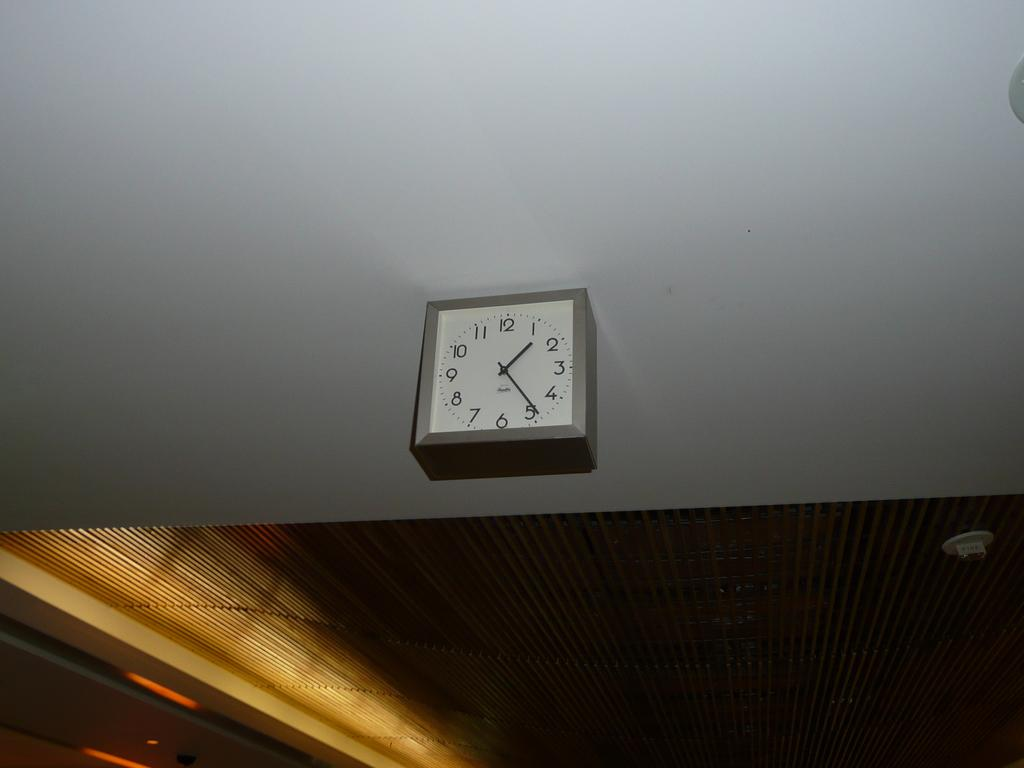<image>
Relay a brief, clear account of the picture shown. white clock on the wall with the hands at 1 and 5. 